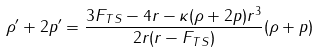Convert formula to latex. <formula><loc_0><loc_0><loc_500><loc_500>\rho ^ { \prime } + 2 p ^ { \prime } = \frac { 3 F _ { T S } - 4 r - \kappa ( \rho + 2 p ) r ^ { 3 } } { 2 r ( r - F _ { T S } ) } ( \rho + p )</formula> 